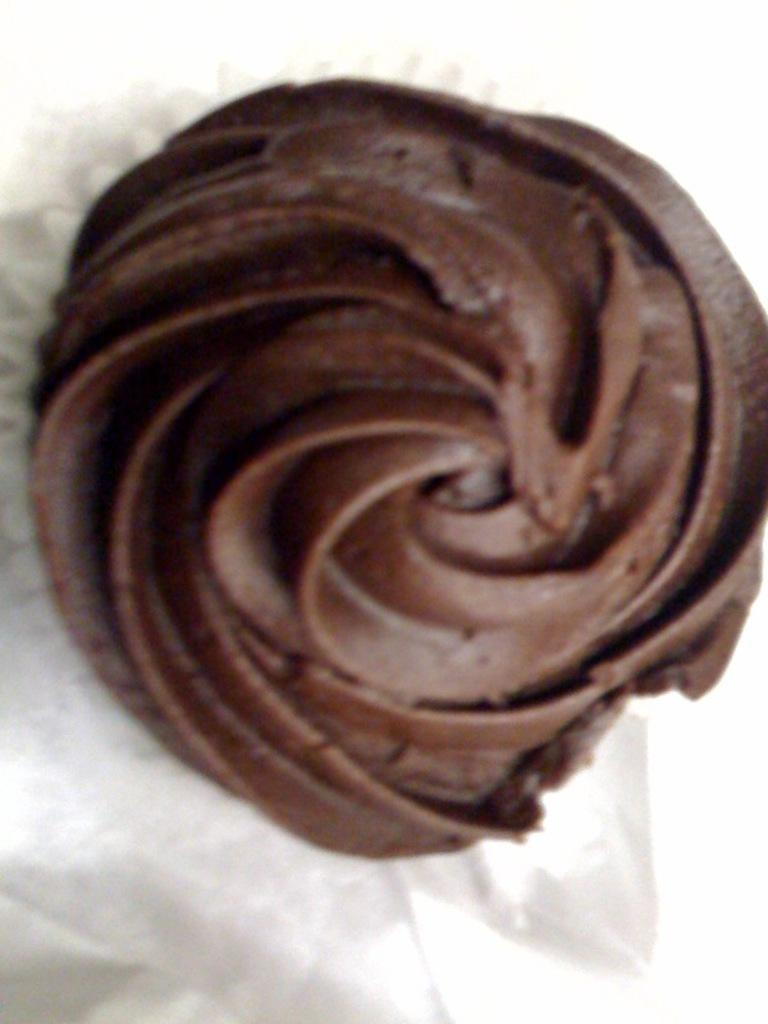What type of food is featured in the image? There is a dessert in the image. What type of wrench is used to prepare the dessert in the image? There is no wrench present in the image, and no indication that a wrench is used to prepare the dessert. 